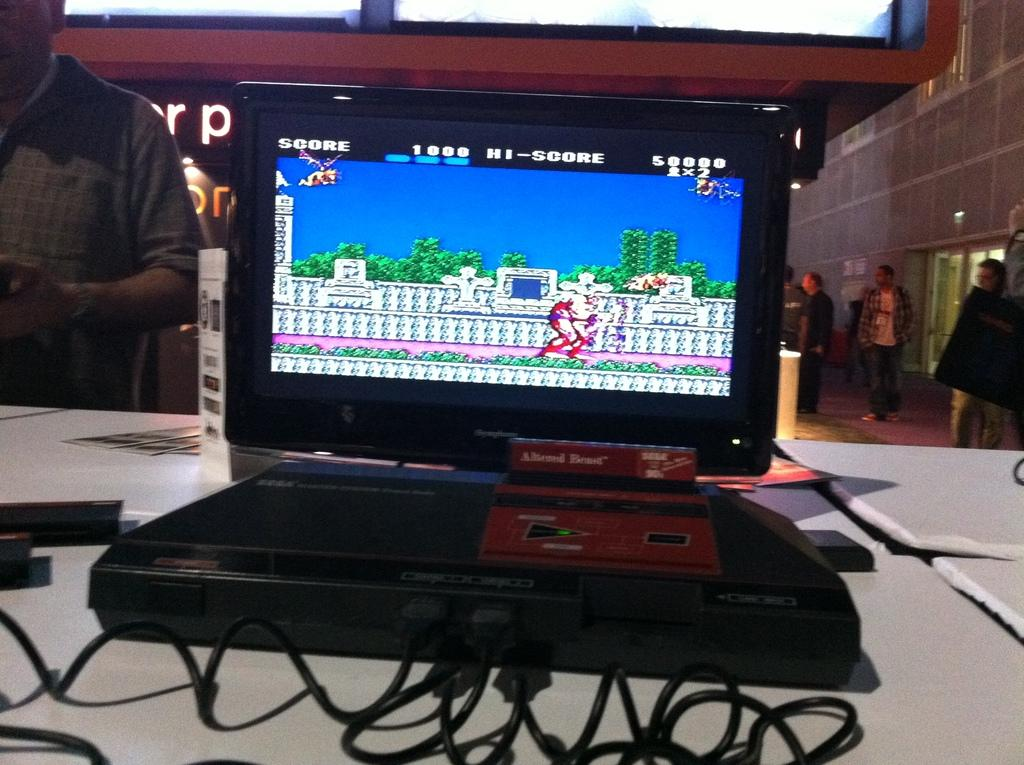<image>
Summarize the visual content of the image. A video game of some sort on a screen that says score in the upper left corner. 